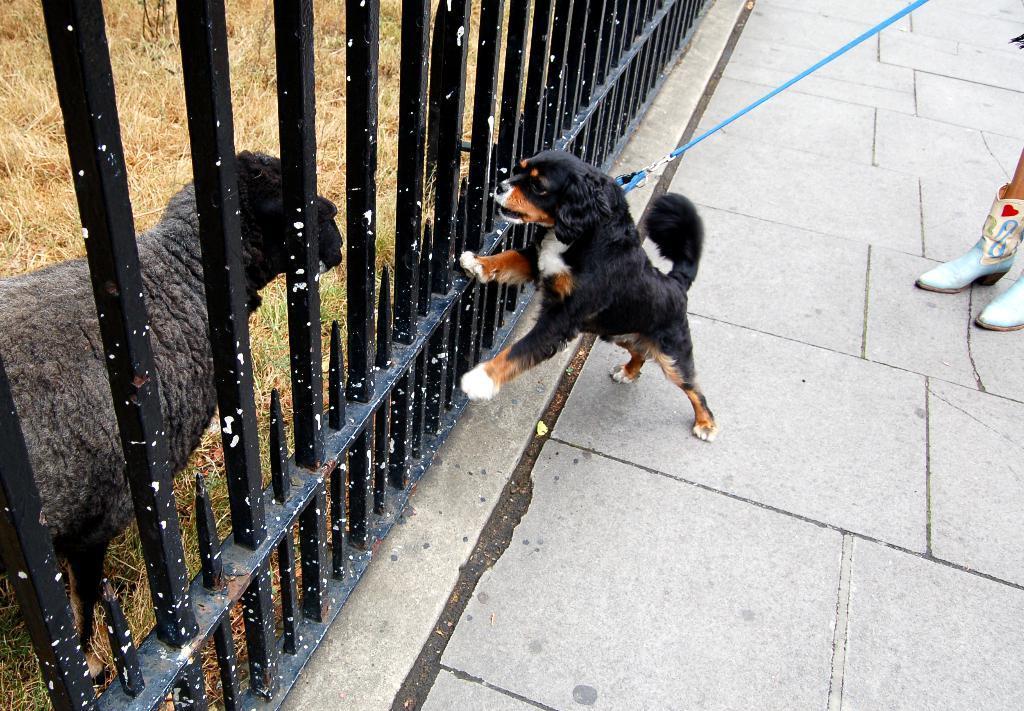Please provide a concise description of this image. In this image we can see a dog with a belt. Near to the dog there is a railing. Beside the railing there is an animal. On the ground there is grass. On the right side we can see legs of a person with footwear. 